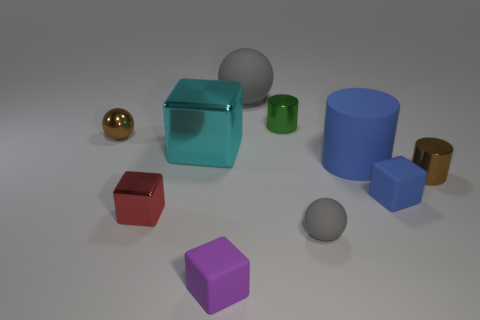Subtract all large shiny blocks. How many blocks are left? 3 Subtract all purple cylinders. How many gray spheres are left? 2 Subtract all blue cylinders. How many cylinders are left? 2 Subtract all cylinders. How many objects are left? 7 Subtract 1 balls. How many balls are left? 2 Subtract all cyan spheres. Subtract all brown cubes. How many spheres are left? 3 Subtract all tiny rubber blocks. Subtract all small cylinders. How many objects are left? 6 Add 8 matte blocks. How many matte blocks are left? 10 Add 3 big yellow matte cylinders. How many big yellow matte cylinders exist? 3 Subtract 0 brown blocks. How many objects are left? 10 